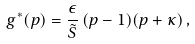<formula> <loc_0><loc_0><loc_500><loc_500>g ^ { * } ( p ) = \frac { \epsilon } { \tilde { S } } \, ( p - 1 ) ( p + \kappa ) \, ,</formula> 